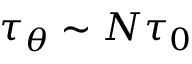<formula> <loc_0><loc_0><loc_500><loc_500>\tau _ { \theta } \sim N \tau _ { 0 }</formula> 